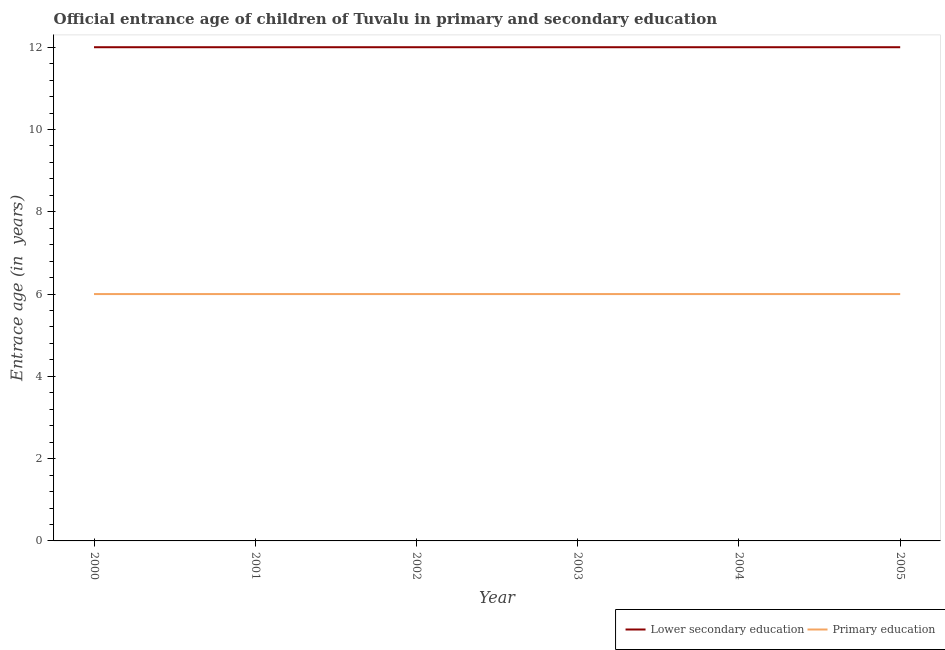What is the entrance age of children in lower secondary education in 2004?
Your answer should be very brief. 12. Across all years, what is the maximum entrance age of children in lower secondary education?
Make the answer very short. 12. Across all years, what is the minimum entrance age of children in lower secondary education?
Give a very brief answer. 12. In which year was the entrance age of children in lower secondary education minimum?
Your answer should be compact. 2000. What is the total entrance age of children in lower secondary education in the graph?
Provide a short and direct response. 72. What is the difference between the entrance age of children in lower secondary education in 2001 and that in 2004?
Give a very brief answer. 0. What is the difference between the entrance age of chiildren in primary education in 2004 and the entrance age of children in lower secondary education in 2003?
Give a very brief answer. -6. In the year 2001, what is the difference between the entrance age of children in lower secondary education and entrance age of chiildren in primary education?
Offer a very short reply. 6. Is the entrance age of chiildren in primary education in 2003 less than that in 2004?
Give a very brief answer. No. Is the difference between the entrance age of chiildren in primary education in 2004 and 2005 greater than the difference between the entrance age of children in lower secondary education in 2004 and 2005?
Your response must be concise. No. What is the difference between the highest and the lowest entrance age of chiildren in primary education?
Make the answer very short. 0. In how many years, is the entrance age of children in lower secondary education greater than the average entrance age of children in lower secondary education taken over all years?
Keep it short and to the point. 0. Is the sum of the entrance age of chiildren in primary education in 2001 and 2005 greater than the maximum entrance age of children in lower secondary education across all years?
Give a very brief answer. No. Is the entrance age of children in lower secondary education strictly greater than the entrance age of chiildren in primary education over the years?
Your response must be concise. Yes. Is the entrance age of children in lower secondary education strictly less than the entrance age of chiildren in primary education over the years?
Your answer should be very brief. No. How many lines are there?
Provide a succinct answer. 2. What is the difference between two consecutive major ticks on the Y-axis?
Make the answer very short. 2. Does the graph contain grids?
Your answer should be very brief. No. How many legend labels are there?
Your answer should be very brief. 2. What is the title of the graph?
Keep it short and to the point. Official entrance age of children of Tuvalu in primary and secondary education. Does "Pregnant women" appear as one of the legend labels in the graph?
Provide a short and direct response. No. What is the label or title of the X-axis?
Ensure brevity in your answer.  Year. What is the label or title of the Y-axis?
Ensure brevity in your answer.  Entrace age (in  years). What is the Entrace age (in  years) of Lower secondary education in 2001?
Your answer should be compact. 12. What is the Entrace age (in  years) of Lower secondary education in 2002?
Provide a succinct answer. 12. What is the Entrace age (in  years) in Lower secondary education in 2003?
Your answer should be very brief. 12. What is the Entrace age (in  years) of Primary education in 2005?
Make the answer very short. 6. Across all years, what is the maximum Entrace age (in  years) of Lower secondary education?
Your answer should be very brief. 12. Across all years, what is the minimum Entrace age (in  years) in Lower secondary education?
Your response must be concise. 12. Across all years, what is the minimum Entrace age (in  years) of Primary education?
Give a very brief answer. 6. What is the total Entrace age (in  years) in Primary education in the graph?
Make the answer very short. 36. What is the difference between the Entrace age (in  years) in Lower secondary education in 2000 and that in 2001?
Your answer should be very brief. 0. What is the difference between the Entrace age (in  years) of Primary education in 2000 and that in 2002?
Give a very brief answer. 0. What is the difference between the Entrace age (in  years) in Lower secondary education in 2000 and that in 2004?
Provide a succinct answer. 0. What is the difference between the Entrace age (in  years) of Primary education in 2000 and that in 2004?
Provide a succinct answer. 0. What is the difference between the Entrace age (in  years) of Lower secondary education in 2000 and that in 2005?
Offer a terse response. 0. What is the difference between the Entrace age (in  years) of Primary education in 2000 and that in 2005?
Your answer should be very brief. 0. What is the difference between the Entrace age (in  years) in Primary education in 2001 and that in 2002?
Offer a terse response. 0. What is the difference between the Entrace age (in  years) in Lower secondary education in 2001 and that in 2003?
Ensure brevity in your answer.  0. What is the difference between the Entrace age (in  years) in Primary education in 2001 and that in 2003?
Your answer should be very brief. 0. What is the difference between the Entrace age (in  years) of Primary education in 2001 and that in 2004?
Ensure brevity in your answer.  0. What is the difference between the Entrace age (in  years) in Lower secondary education in 2002 and that in 2003?
Offer a very short reply. 0. What is the difference between the Entrace age (in  years) in Lower secondary education in 2002 and that in 2005?
Offer a terse response. 0. What is the difference between the Entrace age (in  years) of Lower secondary education in 2003 and that in 2004?
Make the answer very short. 0. What is the difference between the Entrace age (in  years) in Primary education in 2003 and that in 2004?
Ensure brevity in your answer.  0. What is the difference between the Entrace age (in  years) in Lower secondary education in 2004 and that in 2005?
Provide a succinct answer. 0. What is the difference between the Entrace age (in  years) in Lower secondary education in 2000 and the Entrace age (in  years) in Primary education in 2002?
Keep it short and to the point. 6. What is the difference between the Entrace age (in  years) in Lower secondary education in 2001 and the Entrace age (in  years) in Primary education in 2004?
Provide a succinct answer. 6. What is the difference between the Entrace age (in  years) of Lower secondary education in 2002 and the Entrace age (in  years) of Primary education in 2005?
Your answer should be compact. 6. What is the difference between the Entrace age (in  years) in Lower secondary education in 2003 and the Entrace age (in  years) in Primary education in 2005?
Provide a succinct answer. 6. What is the difference between the Entrace age (in  years) in Lower secondary education in 2004 and the Entrace age (in  years) in Primary education in 2005?
Ensure brevity in your answer.  6. What is the average Entrace age (in  years) in Primary education per year?
Make the answer very short. 6. In the year 2000, what is the difference between the Entrace age (in  years) in Lower secondary education and Entrace age (in  years) in Primary education?
Keep it short and to the point. 6. In the year 2002, what is the difference between the Entrace age (in  years) in Lower secondary education and Entrace age (in  years) in Primary education?
Offer a very short reply. 6. What is the ratio of the Entrace age (in  years) in Lower secondary education in 2000 to that in 2001?
Offer a terse response. 1. What is the ratio of the Entrace age (in  years) of Primary education in 2000 to that in 2001?
Offer a terse response. 1. What is the ratio of the Entrace age (in  years) of Lower secondary education in 2000 to that in 2003?
Offer a very short reply. 1. What is the ratio of the Entrace age (in  years) in Lower secondary education in 2000 to that in 2005?
Provide a succinct answer. 1. What is the ratio of the Entrace age (in  years) of Primary education in 2001 to that in 2004?
Provide a short and direct response. 1. What is the ratio of the Entrace age (in  years) of Lower secondary education in 2001 to that in 2005?
Provide a succinct answer. 1. What is the ratio of the Entrace age (in  years) of Primary education in 2001 to that in 2005?
Offer a very short reply. 1. What is the ratio of the Entrace age (in  years) of Lower secondary education in 2002 to that in 2003?
Your response must be concise. 1. What is the ratio of the Entrace age (in  years) of Primary education in 2002 to that in 2003?
Provide a succinct answer. 1. What is the ratio of the Entrace age (in  years) in Primary education in 2002 to that in 2005?
Provide a short and direct response. 1. What is the ratio of the Entrace age (in  years) in Lower secondary education in 2003 to that in 2004?
Keep it short and to the point. 1. What is the ratio of the Entrace age (in  years) of Primary education in 2003 to that in 2004?
Offer a very short reply. 1. What is the difference between the highest and the second highest Entrace age (in  years) in Primary education?
Ensure brevity in your answer.  0. What is the difference between the highest and the lowest Entrace age (in  years) of Primary education?
Make the answer very short. 0. 